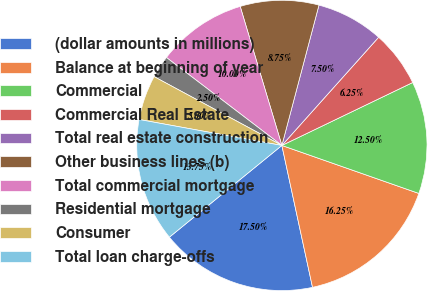<chart> <loc_0><loc_0><loc_500><loc_500><pie_chart><fcel>(dollar amounts in millions)<fcel>Balance at beginning of year<fcel>Commercial<fcel>Commercial Real Estate<fcel>Total real estate construction<fcel>Other business lines (b)<fcel>Total commercial mortgage<fcel>Residential mortgage<fcel>Consumer<fcel>Total loan charge-offs<nl><fcel>17.5%<fcel>16.25%<fcel>12.5%<fcel>6.25%<fcel>7.5%<fcel>8.75%<fcel>10.0%<fcel>2.5%<fcel>5.0%<fcel>13.75%<nl></chart> 